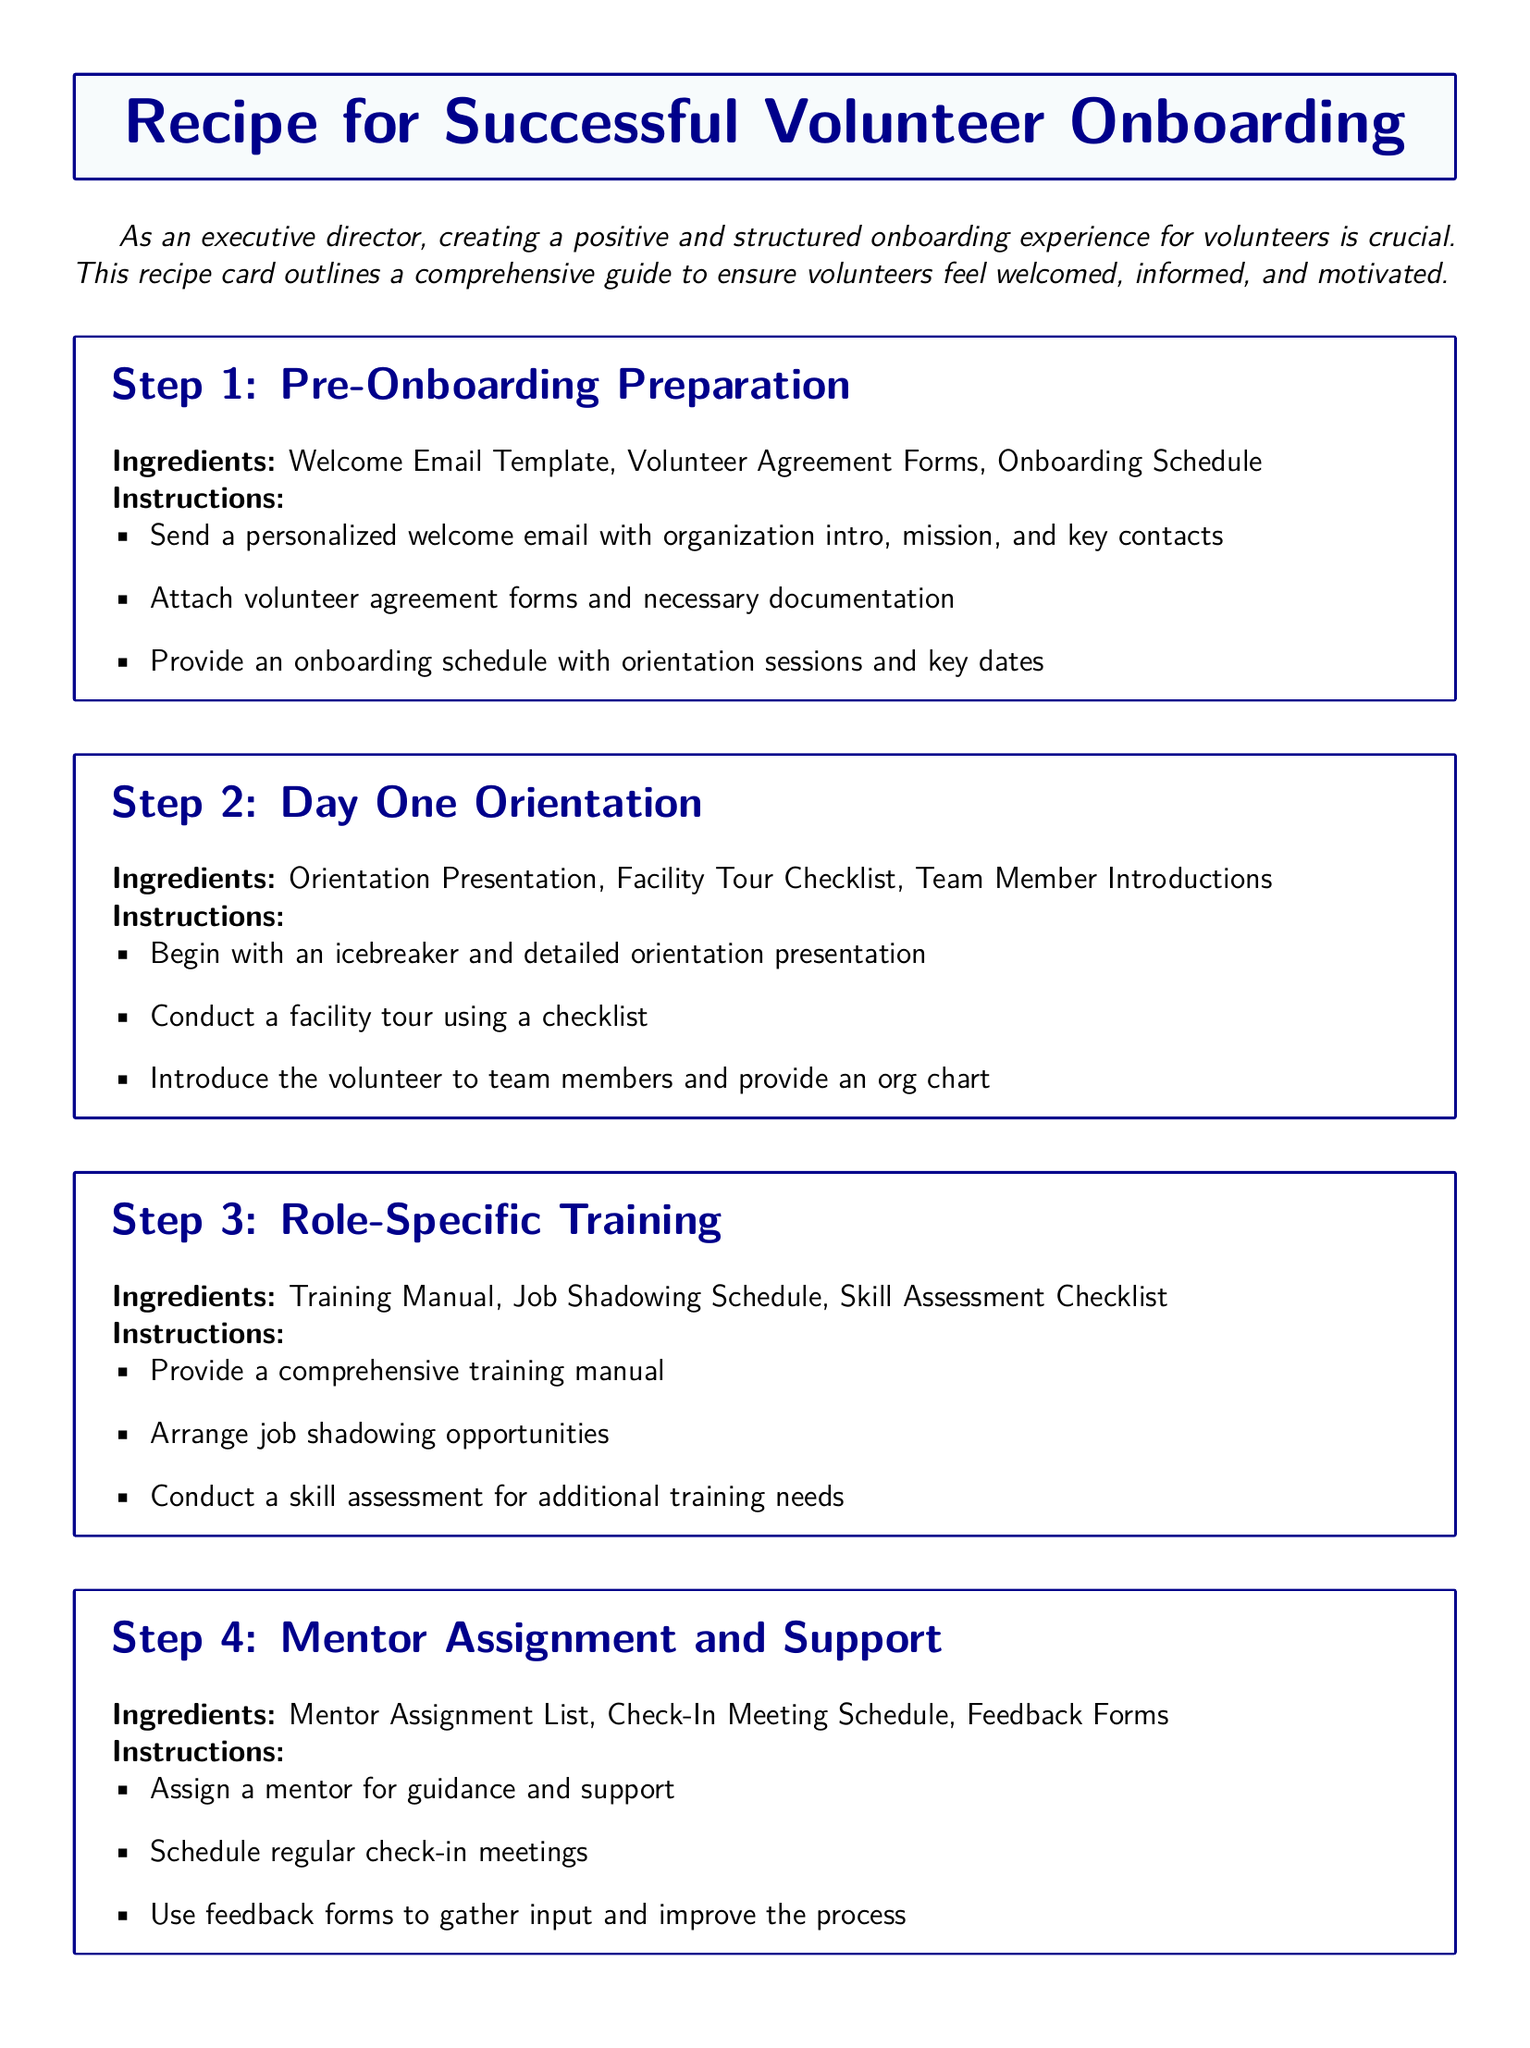What are the first ingredients listed for Step 1? The ingredients for Step 1 include items necessary for pre-onboarding preparation, which are mentioned in the document.
Answer: Welcome Email Template, Volunteer Agreement Forms, Onboarding Schedule How many steps are included in the onboarding recipe? The number of steps can be counted in the document, which outlines a structured approach to volunteer onboarding.
Answer: 5 What should be attached in the welcome email? The document specifies what should be included in the welcome email for effective onboarding.
Answer: Volunteer agreement forms and necessary documentation What is assigned in Step 4? The specific assignment mentioned in Step 4 relates to providing volunteers with additional support.
Answer: Mentor What does Step 5 focus on? The focus of Step 5 can be derived from the title and instructions provided in the document.
Answer: Continuous Engagement and Development What is one of the check-in meeting purposes in Step 4? Understanding the check-in meetings will provide insight into the ongoing support structure for volunteers described in the document.
Answer: To provide guidance and support 